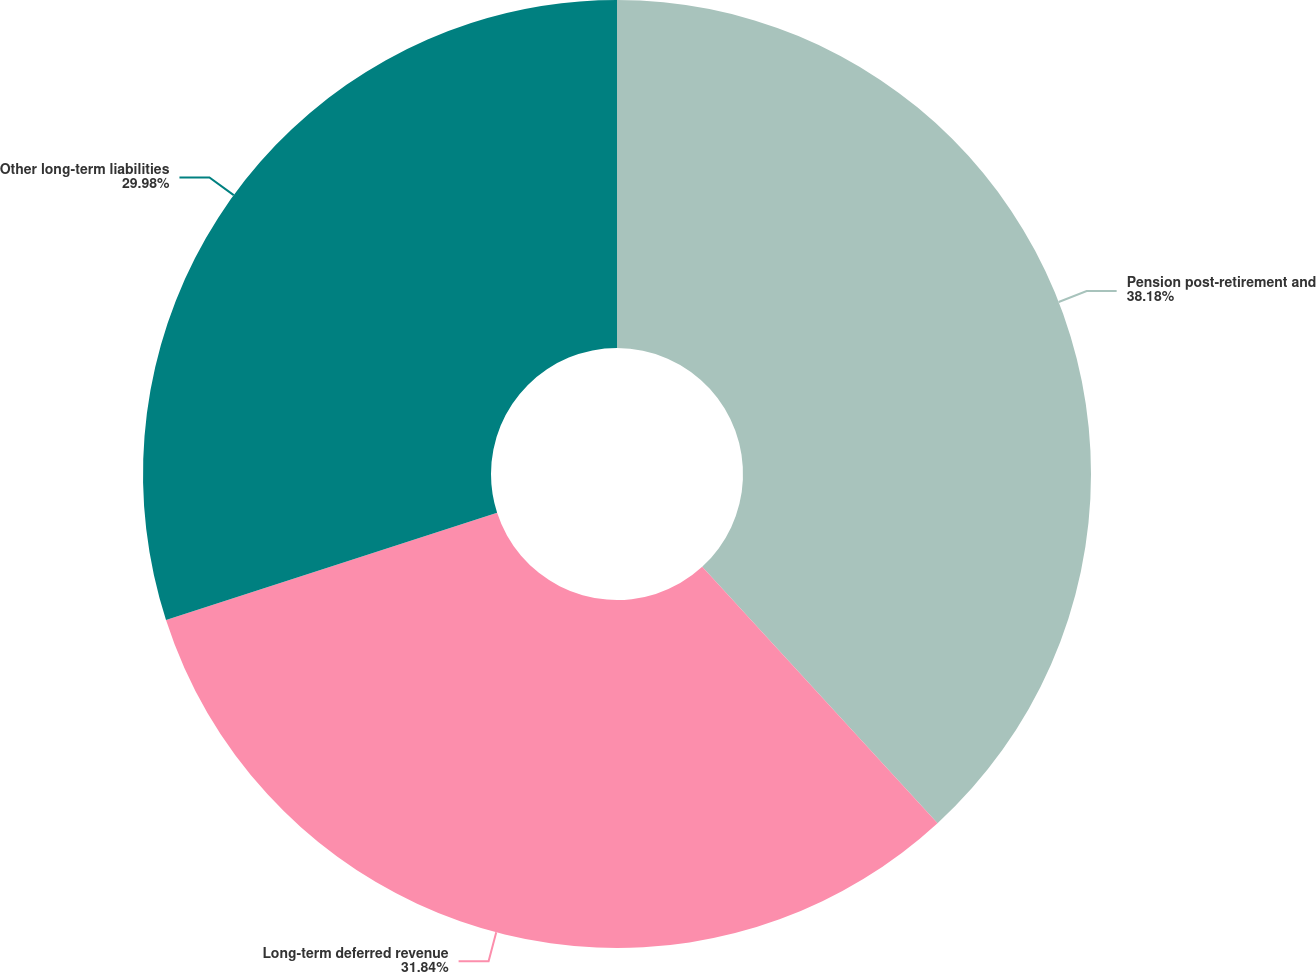Convert chart. <chart><loc_0><loc_0><loc_500><loc_500><pie_chart><fcel>Pension post-retirement and<fcel>Long-term deferred revenue<fcel>Other long-term liabilities<nl><fcel>38.18%<fcel>31.84%<fcel>29.98%<nl></chart> 